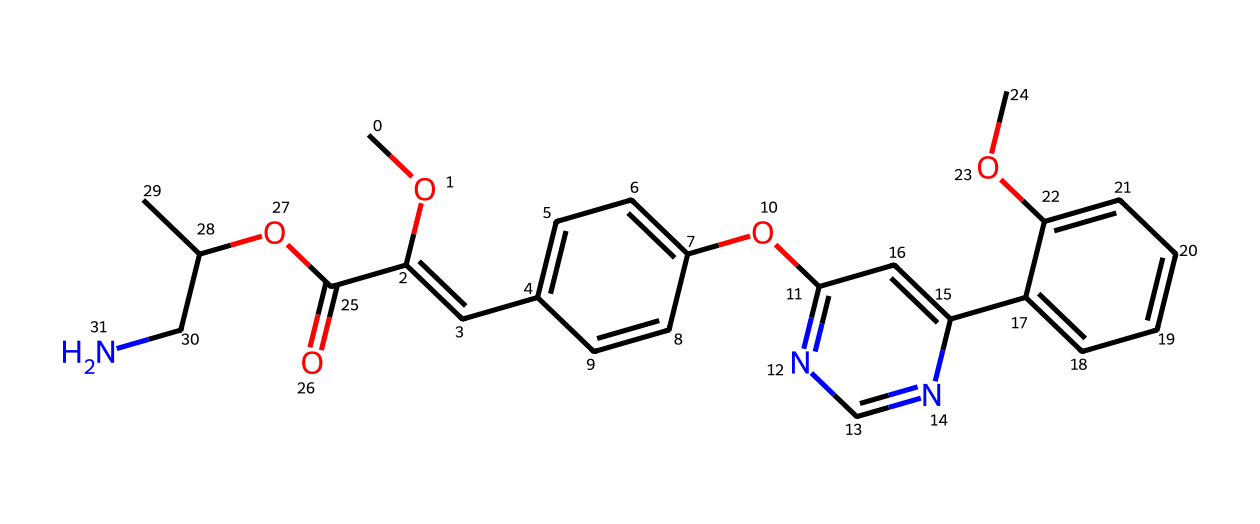What is the molecular formula of azoxystrobin? To determine the molecular formula, one must analyze the SMILES representation for each atom type and count them. Carbon (C), Hydrogen (H), Oxygen (O), and Nitrogen (N) types are present. The total counts include: 20 Carbons, 21 Hydrogens, 5 Oxygens, and 3 Nitrogens, resulting in the molecular formula C20H21N3O5.
Answer: C20H21N3O5 How many rings are present in the chemical structure? By examining the SMILES, we can identify the presence of two cyclic structures (benzenoid systems) and various ring closures. Counts show two interconnected rings due to the 'C' and 'N' presence in cyclic arrangements in the molecule. Therefore, the total number of rings is 2.
Answer: 2 What functional groups are present in azoxystrobin? Looking at the SMILES representation reveals that there are several functional groups present, including an ester (as indicated by "C(=O)O"), ether (indicated by "OC"), and amine (indicated by "CN"). Thus, the identified functional groups are ester, ether, and amine.
Answer: ester, ether, amine What is the role of the nitrogen atoms in this fungicide? In azoxystrobin, nitrogen atoms play a critical role in its activity. The presence of electron-donating nitrogen atoms contributes to the molecule's ability to interact with target enzymes in fungi, thus assisting in fungicidal activity. This characteristic is typical for many fungicide classes, including strobilurins.
Answer: activity How many carbon atoms are bonded to the nitrogen in this molecule? From the SMILES representation, we see that each nitrogen is attached to specific carbon atoms. There are three nitrogen atoms, specifically bonded to three distinct carbon atoms. Therefore, the total number of carbons bonded to nitrogen in this structure is 3.
Answer: 3 What type of fungicide is azoxystrobin classified as? Azoxystrobin is classified as a strobilurin fungicide, which is a group known for its broad-spectrum activity against a variety of fungal pathogens. The structure features key elements that align with this classification, particularly its polycyclic structure with nitrogen heteroatoms.
Answer: strobilurin How does the presence of multiple oxygen atoms affect the solubility of azoxystrobin? The multiple oxygen atoms in the molecule can form hydrogen bonds with water, increasing solubility compared to hydrocarbons. The ether and ester functional groups enhance this interaction, making azoxystrobin more soluble in organic solvents and in some cases in water due to polar interactions.
Answer: increases solubility 